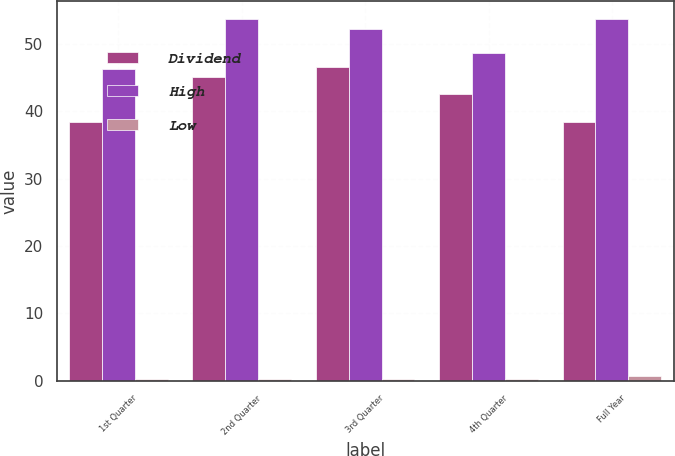Convert chart to OTSL. <chart><loc_0><loc_0><loc_500><loc_500><stacked_bar_chart><ecel><fcel>1st Quarter<fcel>2nd Quarter<fcel>3rd Quarter<fcel>4th Quarter<fcel>Full Year<nl><fcel>Dividend<fcel>38.42<fcel>45.1<fcel>46.63<fcel>42.56<fcel>38.42<nl><fcel>High<fcel>46.36<fcel>53.68<fcel>52.28<fcel>48.7<fcel>53.68<nl><fcel>Low<fcel>0.18<fcel>0.18<fcel>0.18<fcel>0.18<fcel>0.71<nl></chart> 